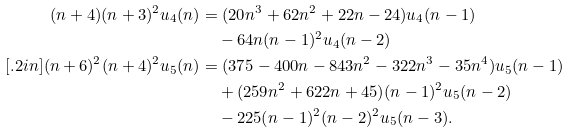Convert formula to latex. <formula><loc_0><loc_0><loc_500><loc_500>( n + 4 ) ( n + 3 ) ^ { 2 } u _ { 4 } ( n ) & = ( 2 0 n ^ { 3 } + 6 2 n ^ { 2 } + 2 2 n - 2 4 ) u _ { 4 } ( n - 1 ) \\ & \quad - 6 4 n ( n - 1 ) ^ { 2 } u _ { 4 } ( n - 2 ) \\ [ . 2 i n ] ( n + 6 ) ^ { 2 } ( n + 4 ) ^ { 2 } u _ { 5 } ( n ) & = ( 3 7 5 - 4 0 0 n - 8 4 3 n ^ { 2 } - 3 2 2 n ^ { 3 } - 3 5 n ^ { 4 } ) u _ { 5 } ( n - 1 ) \\ & \quad + ( 2 5 9 n ^ { 2 } + 6 2 2 n + 4 5 ) ( n - 1 ) ^ { 2 } u _ { 5 } ( n - 2 ) \\ & \quad - 2 2 5 ( n - 1 ) ^ { 2 } ( n - 2 ) ^ { 2 } u _ { 5 } ( n - 3 ) .</formula> 